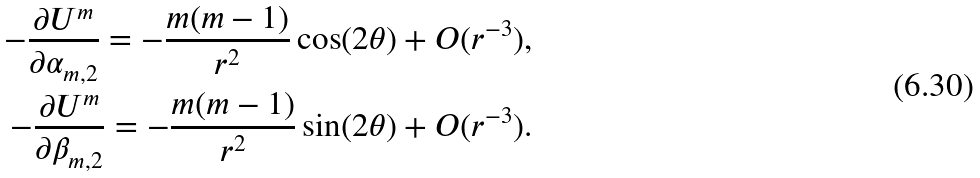Convert formula to latex. <formula><loc_0><loc_0><loc_500><loc_500>- \frac { \partial U ^ { m } } { \partial \alpha _ { m , 2 } } = - \frac { m ( m - 1 ) } { r ^ { 2 } } \cos ( 2 \theta ) + O ( r ^ { - 3 } ) , \\ - \frac { \partial U ^ { m } } { \partial \beta _ { m , 2 } } = - \frac { m ( m - 1 ) } { r ^ { 2 } } \sin ( 2 \theta ) + O ( r ^ { - 3 } ) .</formula> 